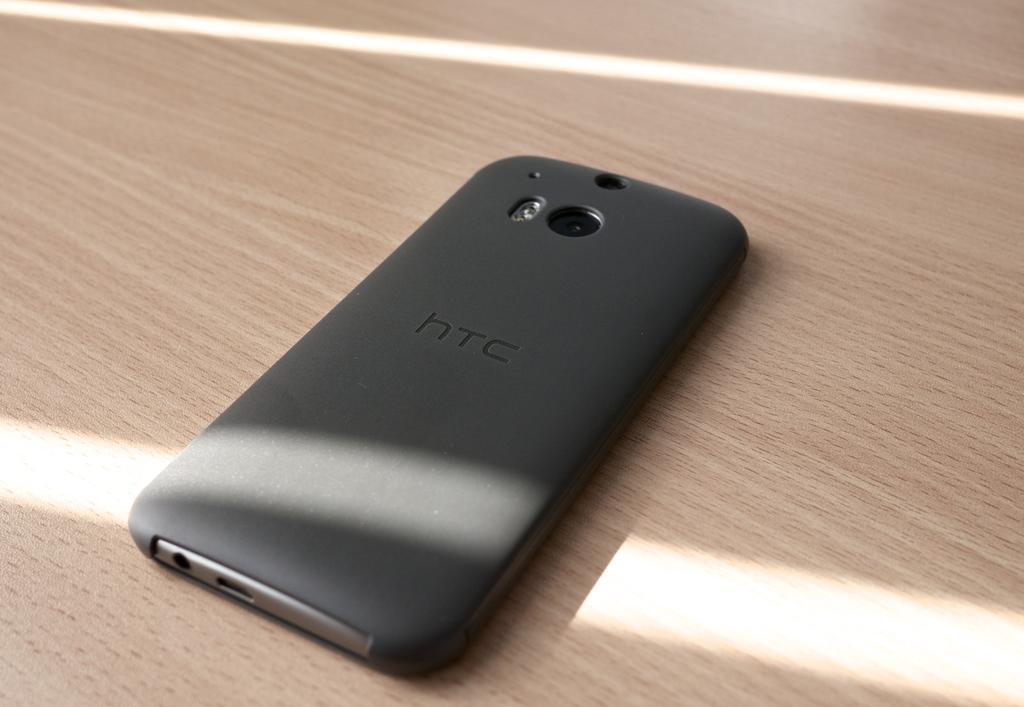<image>
Offer a succinct explanation of the picture presented. a cell phone face down on the desk with the letters htc on it 